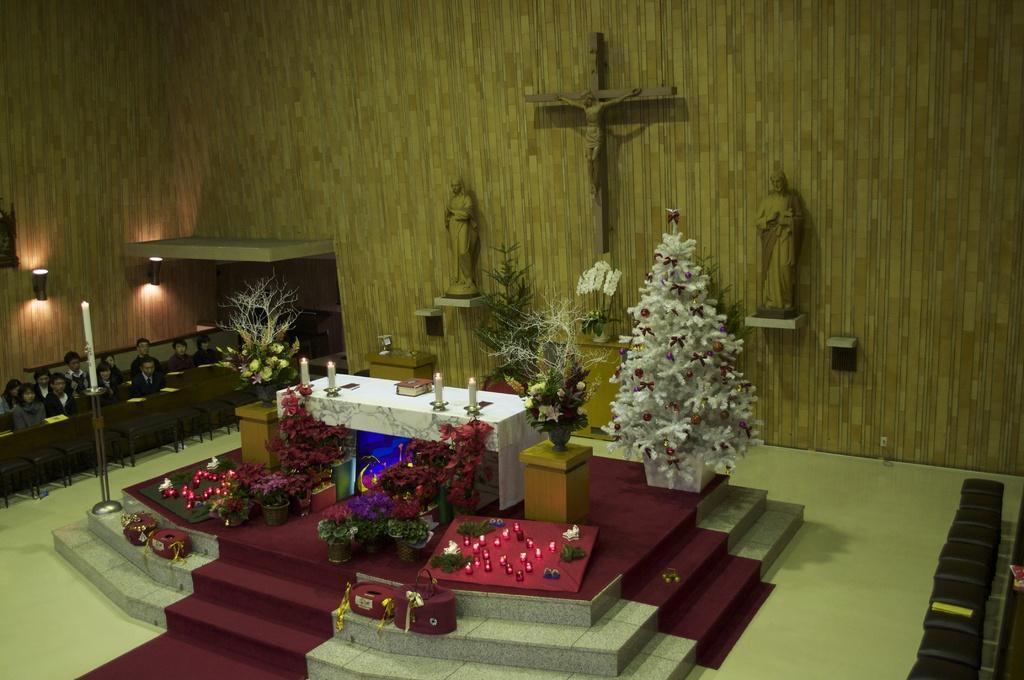Please provide a concise description of this image. This picture might be taken in a church, in this image in the center there is a table. On the table there are some candles and book and also there are some flower pots, plants, lights, boards, christmas tree and stairs. In the background there are some statues and cross and wall, and on the left side of the image there are some people sitting and there are tables and lights and pole. At the bottom there is floor and on the right side of the image there are some chairs. 